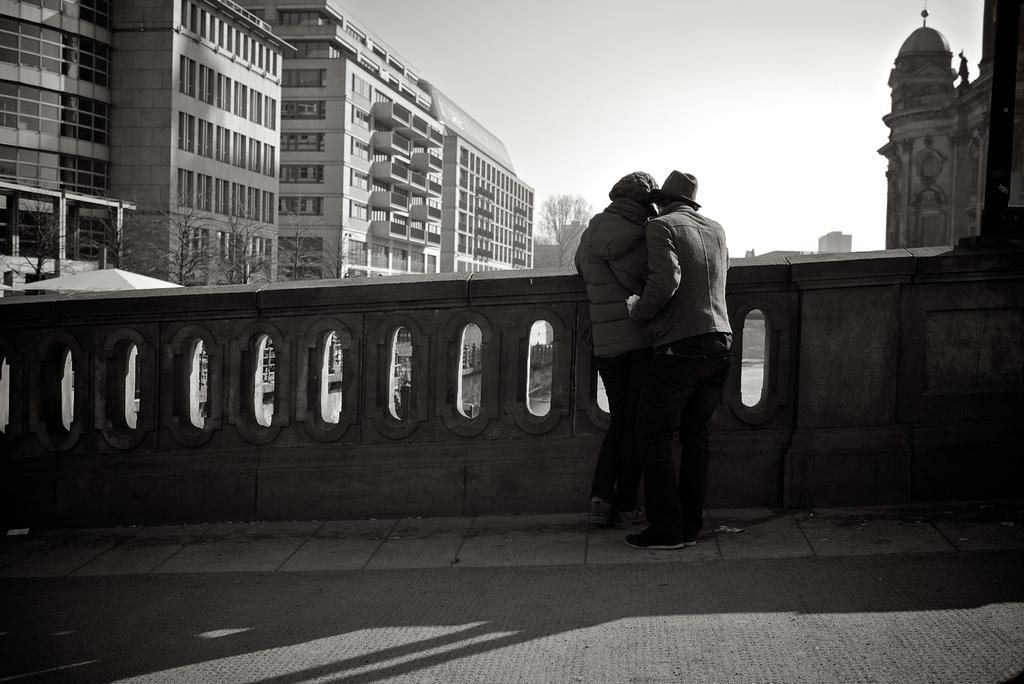What type of structures can be seen in the image? There are buildings in the image. What natural elements are present in the image? There are trees and water visible in the image. What are the people in the image doing? The people are standing on a bridge in the image. Where is the tent located in the image? The tent is on the left side of the image. What is the condition of the sky in the image? The sky is cloudy in the image. Can you tell me how many ministers are present in the image? There is no minister present in the image. What type of knot is being used to secure the tent in the image? There is no knot visible in the image, as the tent is not being secured. Are any mittens visible in the image? There are no mittens present in the image. 